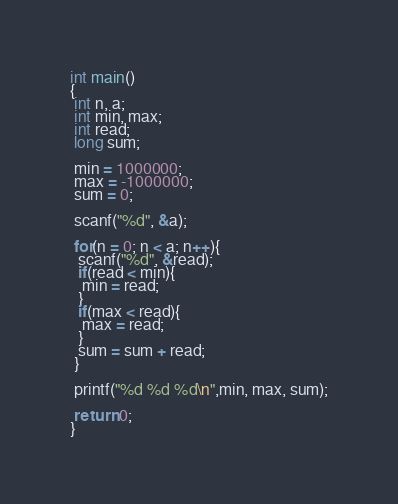<code> <loc_0><loc_0><loc_500><loc_500><_C_>int main()
{
 int n, a;
 int min, max;
 int read;
 long sum;

 min = 1000000;
 max = -1000000;
 sum = 0;

 scanf("%d", &a);

 for(n = 0; n < a; n++){
  scanf("%d", &read);
  if(read < min){
   min = read;
  }
  if(max < read){
   max = read;
  }
  sum = sum + read;
 }

 printf("%d %d %d\n",min, max, sum);

 return 0;
}</code> 